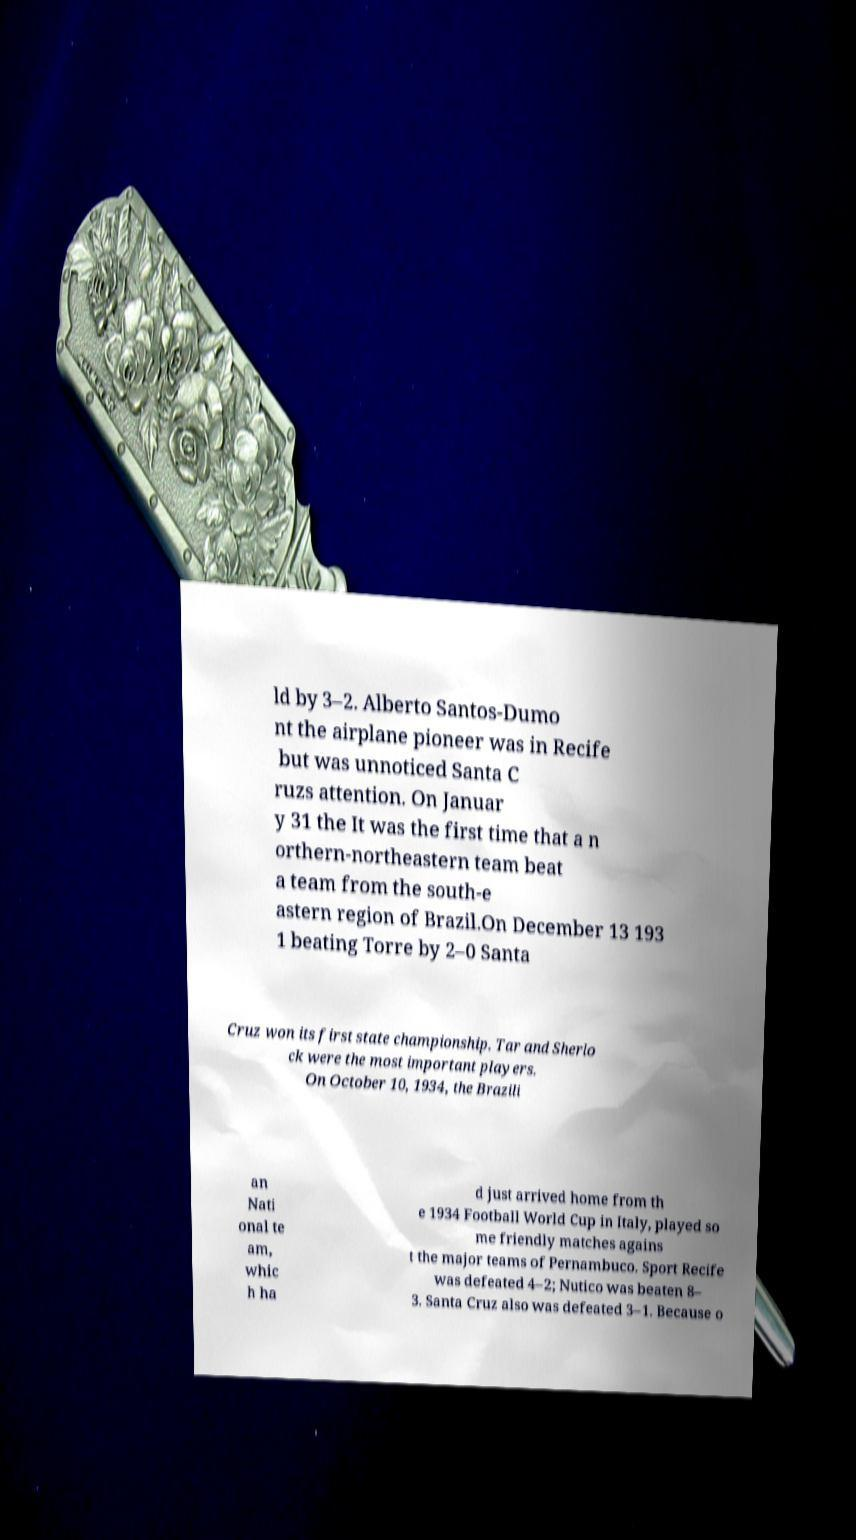Please identify and transcribe the text found in this image. ld by 3–2. Alberto Santos-Dumo nt the airplane pioneer was in Recife but was unnoticed Santa C ruzs attention. On Januar y 31 the It was the first time that a n orthern-northeastern team beat a team from the south-e astern region of Brazil.On December 13 193 1 beating Torre by 2–0 Santa Cruz won its first state championship. Tar and Sherlo ck were the most important players. On October 10, 1934, the Brazili an Nati onal te am, whic h ha d just arrived home from th e 1934 Football World Cup in Italy, played so me friendly matches agains t the major teams of Pernambuco. Sport Recife was defeated 4–2; Nutico was beaten 8– 3. Santa Cruz also was defeated 3–1. Because o 